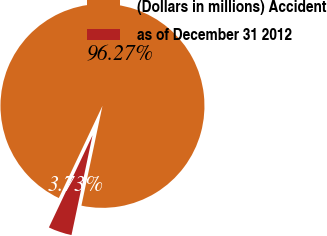<chart> <loc_0><loc_0><loc_500><loc_500><pie_chart><fcel>(Dollars in millions) Accident<fcel>as of December 31 2012<nl><fcel>96.27%<fcel>3.73%<nl></chart> 